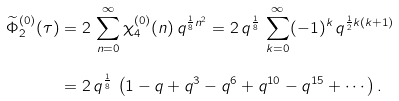<formula> <loc_0><loc_0><loc_500><loc_500>\widetilde { \Phi } _ { 2 } ^ { ( 0 ) } ( \tau ) & = 2 \, \sum _ { n = 0 } ^ { \infty } \chi _ { 4 } ^ { ( 0 ) } ( n ) \, q ^ { \frac { 1 } { 8 } n ^ { 2 } } = 2 \, q ^ { \frac { 1 } { 8 } } \, \sum _ { k = 0 } ^ { \infty } ( - 1 ) ^ { k } \, q ^ { \frac { 1 } { 2 } k ( k + 1 ) } \\ & = 2 \, q ^ { \frac { 1 } { 8 } } \, \left ( 1 - q + q ^ { 3 } - q ^ { 6 } + q ^ { 1 0 } - q ^ { 1 5 } + \cdots \right ) .</formula> 